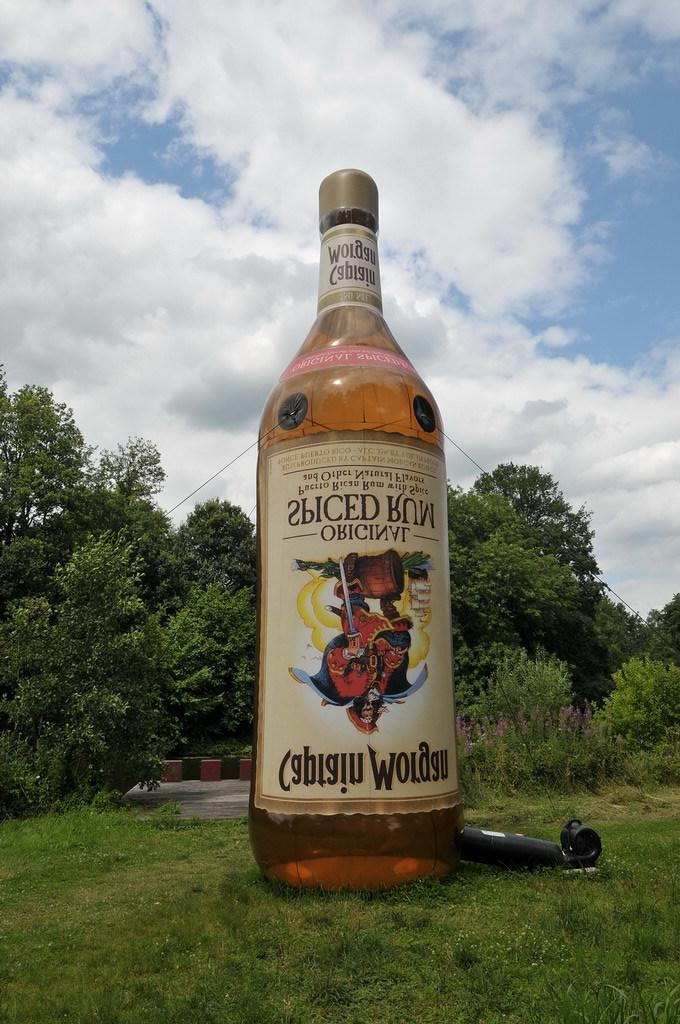<image>
Give a short and clear explanation of the subsequent image. A large inflatable in the shape of a Captain Morgan original spiced rum. 